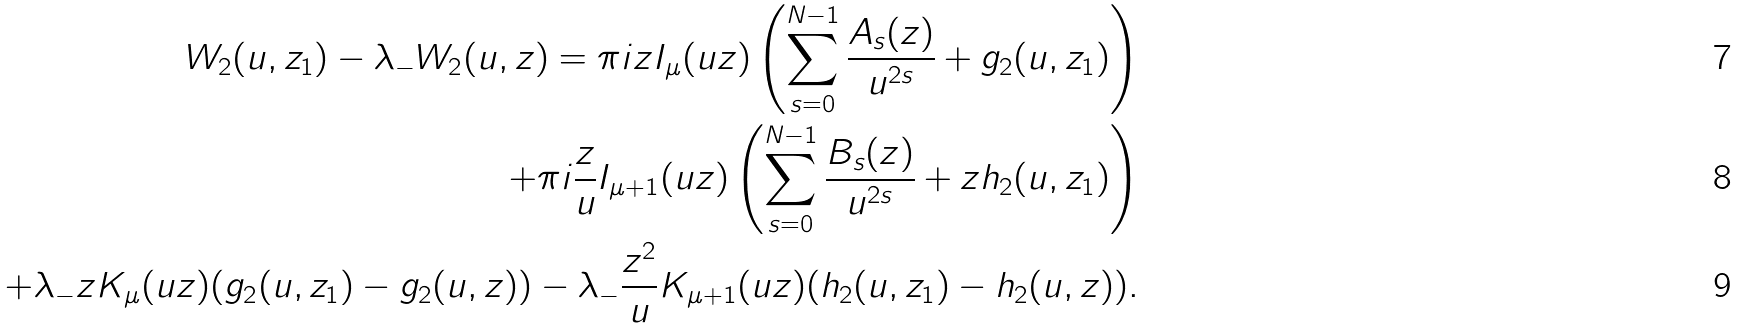Convert formula to latex. <formula><loc_0><loc_0><loc_500><loc_500>W _ { 2 } ( u , z _ { 1 } ) - \lambda _ { - } W _ { 2 } ( u , z ) = \pi i z I _ { \mu } ( u z ) \left ( \sum _ { s = 0 } ^ { N - 1 } \frac { A _ { s } ( z ) } { u ^ { 2 s } } + g _ { 2 } ( u , z _ { 1 } ) \right ) \\ + \pi i \frac { z } { u } I _ { \mu + 1 } ( u z ) \left ( \sum _ { s = 0 } ^ { N - 1 } \frac { B _ { s } ( z ) } { u ^ { 2 s } } + z h _ { 2 } ( u , z _ { 1 } ) \right ) \\ + \lambda _ { - } z K _ { \mu } ( u z ) ( g _ { 2 } ( u , z _ { 1 } ) - g _ { 2 } ( u , z ) ) - \lambda _ { - } \frac { z ^ { 2 } } { u } K _ { \mu + 1 } ( u z ) ( h _ { 2 } ( u , z _ { 1 } ) - h _ { 2 } ( u , z ) ) .</formula> 